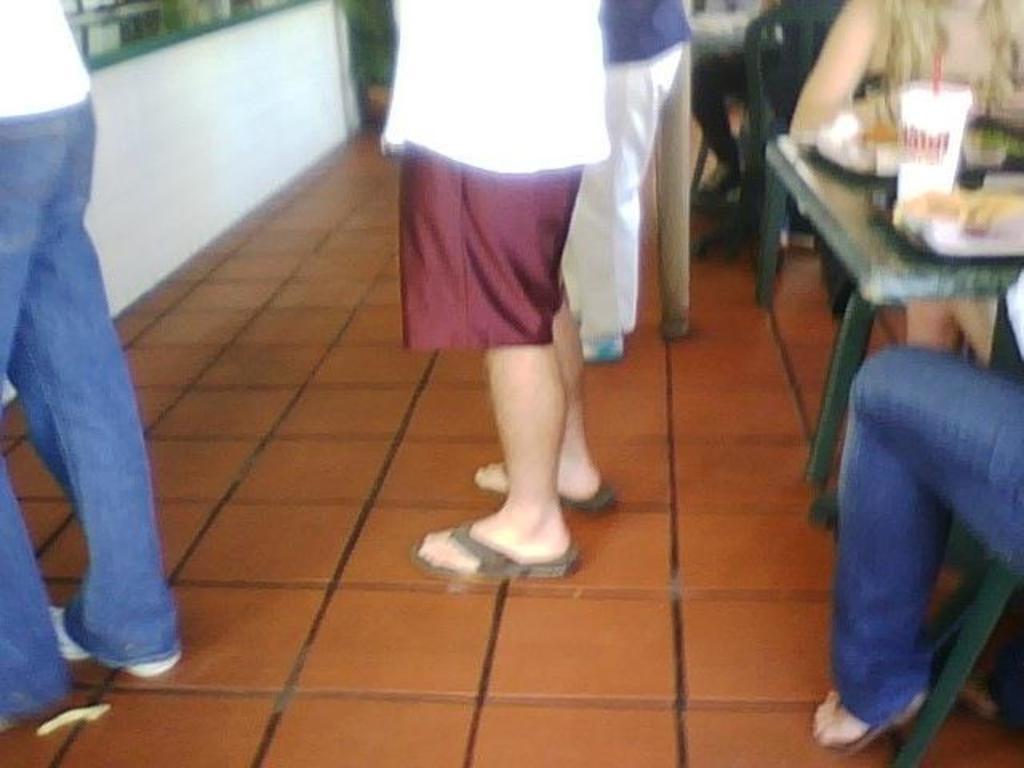Can you describe this image briefly? In this picture there are three persons who are standing. There is a woman and a man sitting on the chair to the right side. A cup is visible on the table. 